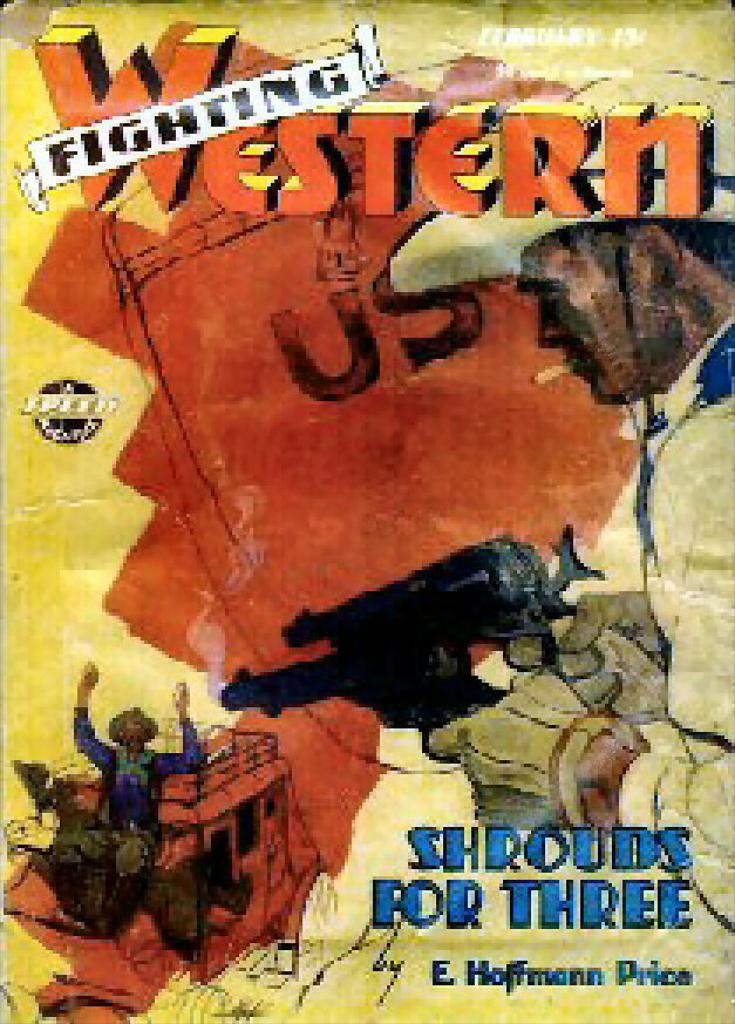<image>
Give a short and clear explanation of the subsequent image. A cowboy holds two guns on the cover for Shrouds for Three. 